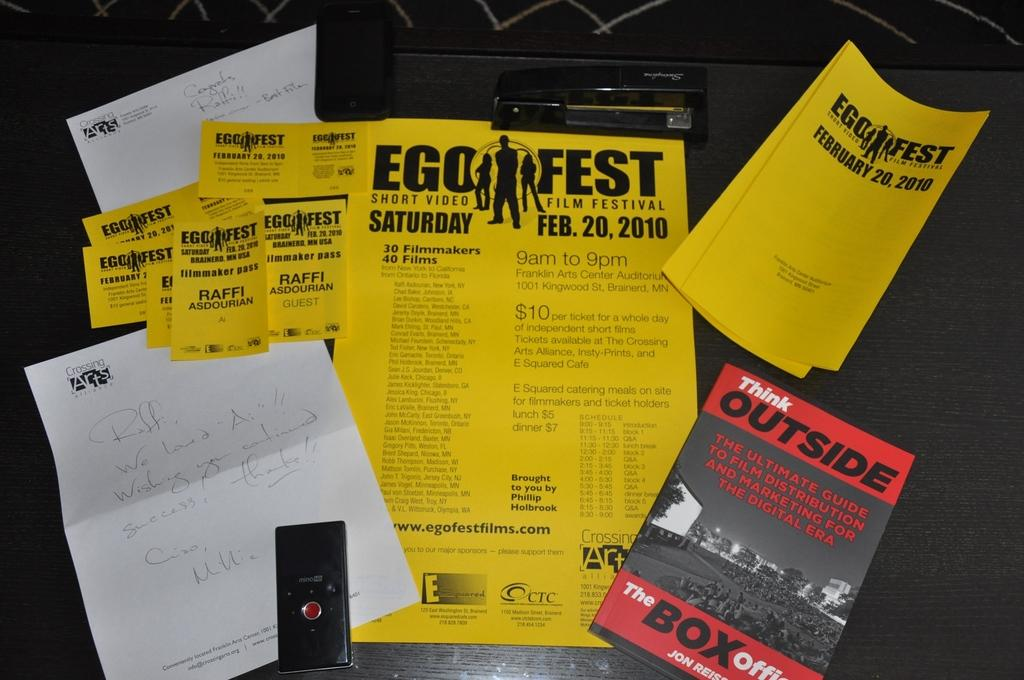What type of reading materials are present in the image? There are papers and magazines in the image. Where are the papers and magazines located? The papers and magazines are on an exam pad. What is visible in the background of the image? There is a table in the background of the image. What type of letter is being used to apply force on the umbrella in the image? There is no letter or umbrella present in the image. How is the force being applied to the umbrella in the image? There is no umbrella present in the image, so it is not possible to determine how force might be applied to it. 